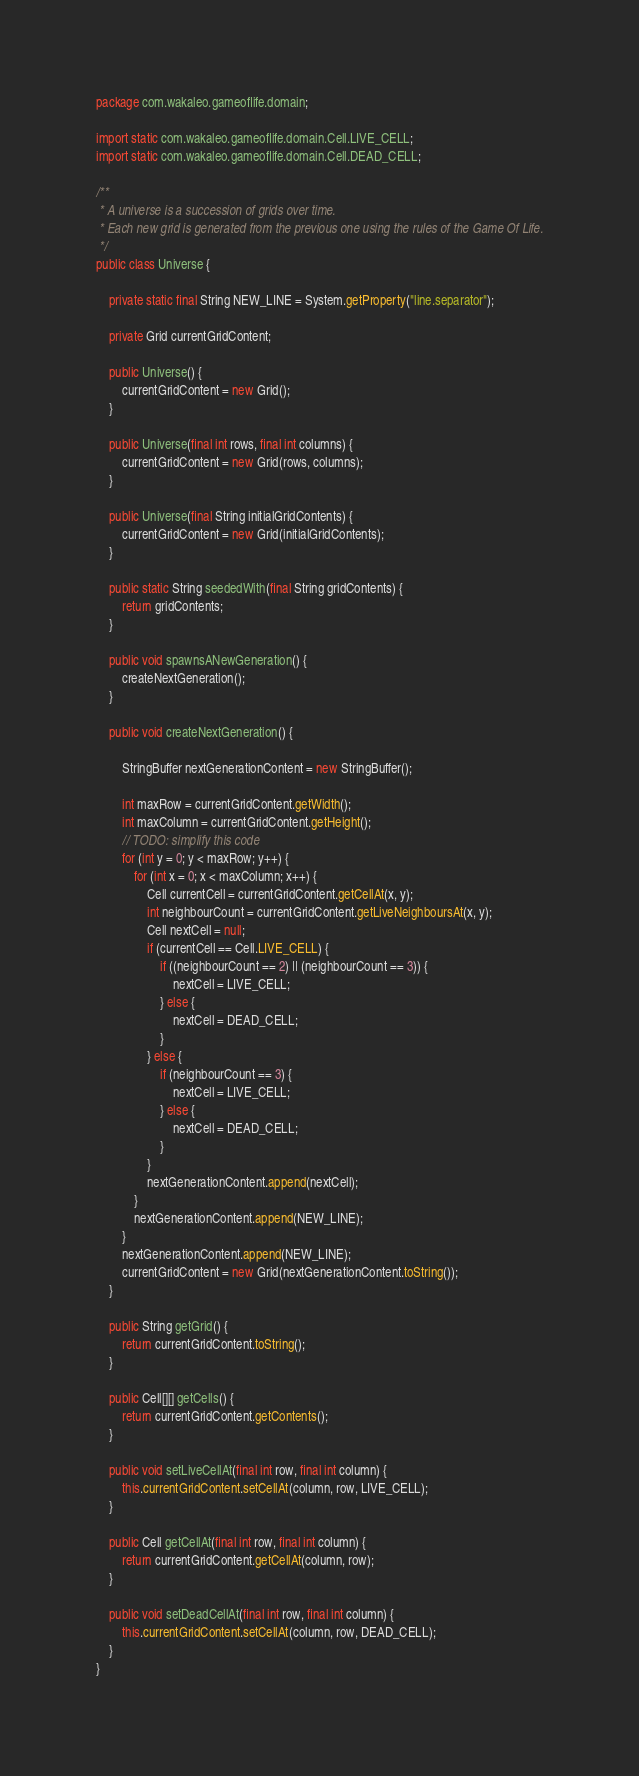Convert code to text. <code><loc_0><loc_0><loc_500><loc_500><_Java_>package com.wakaleo.gameoflife.domain;

import static com.wakaleo.gameoflife.domain.Cell.LIVE_CELL;
import static com.wakaleo.gameoflife.domain.Cell.DEAD_CELL;

/**
 * A universe is a succession of grids over time.
 * Each new grid is generated from the previous one using the rules of the Game Of Life.
 */
public class Universe {

    private static final String NEW_LINE = System.getProperty("line.separator");

    private Grid currentGridContent;

    public Universe() {
        currentGridContent = new Grid();
    }

    public Universe(final int rows, final int columns) {
        currentGridContent = new Grid(rows, columns);
    }

    public Universe(final String initialGridContents) {
        currentGridContent = new Grid(initialGridContents);
    }

    public static String seededWith(final String gridContents) {
        return gridContents;
    }

    public void spawnsANewGeneration() {
        createNextGeneration();
    }

    public void createNextGeneration() {

        StringBuffer nextGenerationContent = new StringBuffer();

        int maxRow = currentGridContent.getWidth();
        int maxColumn = currentGridContent.getHeight();
        // TODO: simplify this code
        for (int y = 0; y < maxRow; y++) {
            for (int x = 0; x < maxColumn; x++) {
                Cell currentCell = currentGridContent.getCellAt(x, y);
                int neighbourCount = currentGridContent.getLiveNeighboursAt(x, y);
                Cell nextCell = null;
                if (currentCell == Cell.LIVE_CELL) {
                    if ((neighbourCount == 2) || (neighbourCount == 3)) {
                        nextCell = LIVE_CELL;
                    } else {
                        nextCell = DEAD_CELL;
                    }
                } else {
                    if (neighbourCount == 3) {
                        nextCell = LIVE_CELL;
                    } else {
                        nextCell = DEAD_CELL;
                    }
                }
                nextGenerationContent.append(nextCell);
            }
            nextGenerationContent.append(NEW_LINE);
        }
        nextGenerationContent.append(NEW_LINE);
        currentGridContent = new Grid(nextGenerationContent.toString());
    }

    public String getGrid() {
        return currentGridContent.toString();
    }

    public Cell[][] getCells() {
        return currentGridContent.getContents();
    }

    public void setLiveCellAt(final int row, final int column) {
        this.currentGridContent.setCellAt(column, row, LIVE_CELL);
    }

    public Cell getCellAt(final int row, final int column) {
        return currentGridContent.getCellAt(column, row);
    }

    public void setDeadCellAt(final int row, final int column) {
        this.currentGridContent.setCellAt(column, row, DEAD_CELL);
    }
}
</code> 